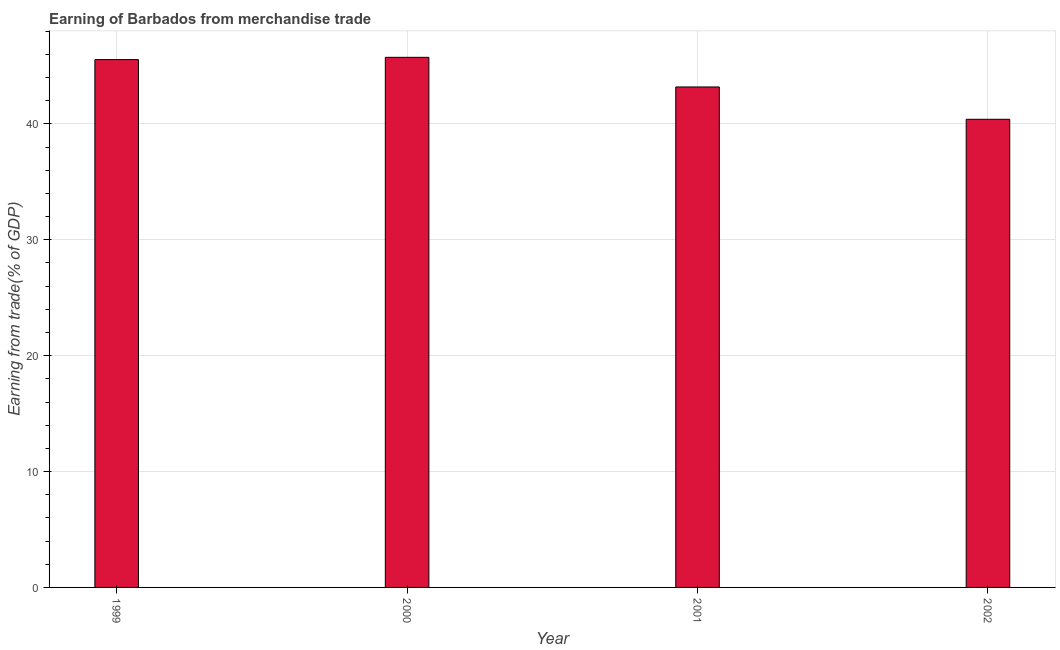Does the graph contain grids?
Ensure brevity in your answer.  Yes. What is the title of the graph?
Give a very brief answer. Earning of Barbados from merchandise trade. What is the label or title of the X-axis?
Offer a terse response. Year. What is the label or title of the Y-axis?
Your response must be concise. Earning from trade(% of GDP). What is the earning from merchandise trade in 2002?
Offer a very short reply. 40.4. Across all years, what is the maximum earning from merchandise trade?
Offer a terse response. 45.75. Across all years, what is the minimum earning from merchandise trade?
Your answer should be very brief. 40.4. In which year was the earning from merchandise trade maximum?
Offer a terse response. 2000. What is the sum of the earning from merchandise trade?
Ensure brevity in your answer.  174.89. What is the difference between the earning from merchandise trade in 1999 and 2001?
Keep it short and to the point. 2.36. What is the average earning from merchandise trade per year?
Keep it short and to the point. 43.72. What is the median earning from merchandise trade?
Your response must be concise. 44.37. In how many years, is the earning from merchandise trade greater than 42 %?
Give a very brief answer. 3. Do a majority of the years between 2002 and 2001 (inclusive) have earning from merchandise trade greater than 36 %?
Provide a succinct answer. No. What is the ratio of the earning from merchandise trade in 1999 to that in 2002?
Keep it short and to the point. 1.13. Is the earning from merchandise trade in 2000 less than that in 2002?
Make the answer very short. No. What is the difference between the highest and the second highest earning from merchandise trade?
Your response must be concise. 0.2. What is the difference between the highest and the lowest earning from merchandise trade?
Your response must be concise. 5.35. In how many years, is the earning from merchandise trade greater than the average earning from merchandise trade taken over all years?
Make the answer very short. 2. Are all the bars in the graph horizontal?
Keep it short and to the point. No. How many years are there in the graph?
Your answer should be compact. 4. What is the difference between two consecutive major ticks on the Y-axis?
Your answer should be very brief. 10. Are the values on the major ticks of Y-axis written in scientific E-notation?
Your response must be concise. No. What is the Earning from trade(% of GDP) of 1999?
Your answer should be compact. 45.55. What is the Earning from trade(% of GDP) of 2000?
Ensure brevity in your answer.  45.75. What is the Earning from trade(% of GDP) in 2001?
Offer a very short reply. 43.19. What is the Earning from trade(% of GDP) of 2002?
Provide a short and direct response. 40.4. What is the difference between the Earning from trade(% of GDP) in 1999 and 2000?
Provide a succinct answer. -0.2. What is the difference between the Earning from trade(% of GDP) in 1999 and 2001?
Ensure brevity in your answer.  2.36. What is the difference between the Earning from trade(% of GDP) in 1999 and 2002?
Your response must be concise. 5.15. What is the difference between the Earning from trade(% of GDP) in 2000 and 2001?
Your answer should be compact. 2.56. What is the difference between the Earning from trade(% of GDP) in 2000 and 2002?
Ensure brevity in your answer.  5.35. What is the difference between the Earning from trade(% of GDP) in 2001 and 2002?
Provide a short and direct response. 2.79. What is the ratio of the Earning from trade(% of GDP) in 1999 to that in 2000?
Your response must be concise. 1. What is the ratio of the Earning from trade(% of GDP) in 1999 to that in 2001?
Offer a terse response. 1.05. What is the ratio of the Earning from trade(% of GDP) in 1999 to that in 2002?
Give a very brief answer. 1.13. What is the ratio of the Earning from trade(% of GDP) in 2000 to that in 2001?
Provide a short and direct response. 1.06. What is the ratio of the Earning from trade(% of GDP) in 2000 to that in 2002?
Make the answer very short. 1.13. What is the ratio of the Earning from trade(% of GDP) in 2001 to that in 2002?
Provide a short and direct response. 1.07. 